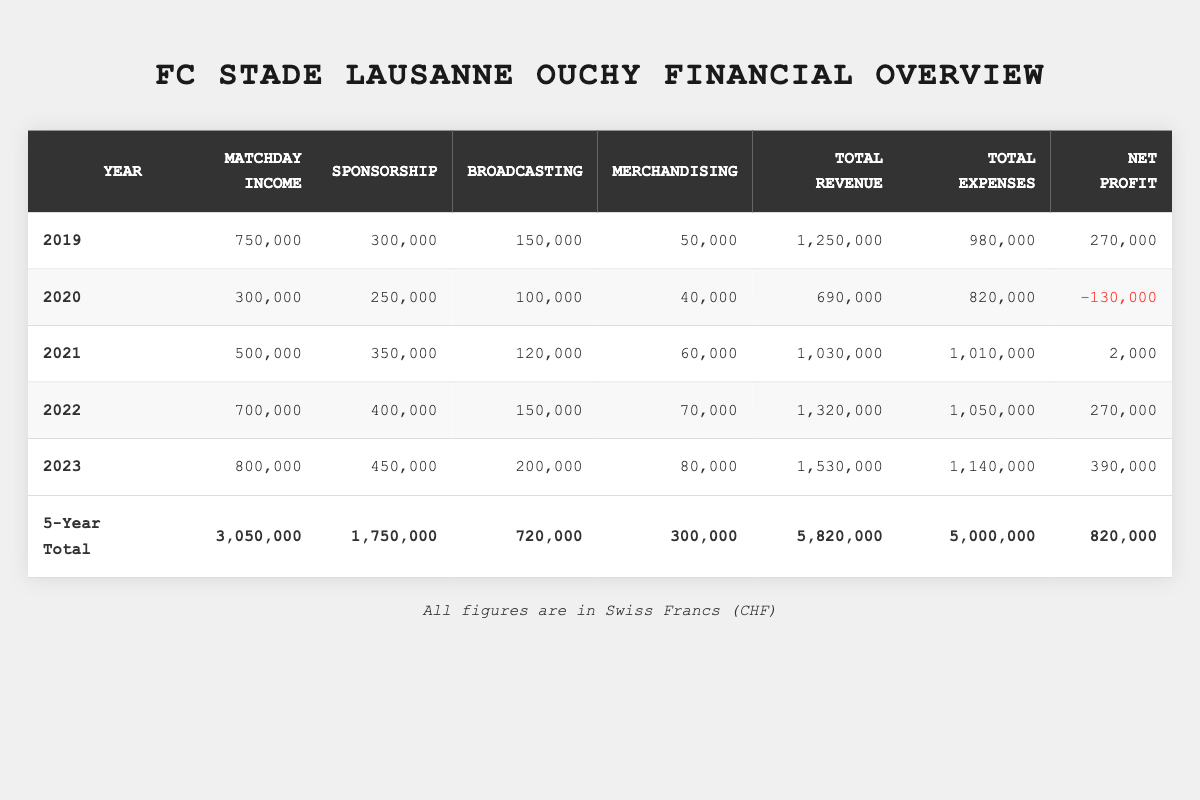What was the total revenue for FC Stade Lausanne Ouchy in 2022? The table shows that the total revenue for 2022 is listed directly under the "Total Revenue" column, which is 1,320,000 CHF.
Answer: 1,320,000 CHF What were the matchday income and total expenses in 2021? The matchday income for 2021 can be found directly in the table as 500,000 CHF, and total expenses are listed as 1,010,000 CHF.
Answer: Matchday income: 500,000 CHF; Total expenses: 1,010,000 CHF In which year did FC Stade Lausanne Ouchy first report a negative net profit? By examining the "Net Profit" column, we find that 2020 shows a negative value of -130,000 CHF.
Answer: 2020 What is the percentage increase in total revenue from 2021 to 2022? The total revenue in 2021 is 1,030,000 CHF and in 2022 it is 1,320,000 CHF. The increase is 1,320,000 - 1,030,000 = 290,000 CHF. To find the percentage increase, we divide by the original amount: (290,000 / 1,030,000) * 100% = approximately 28.16%.
Answer: Approximately 28.16% What was the average net profit over the five years? To find the average net profit, we first sum the net profits: 270,000 + (-130,000) + 2,000 + 270,000 + 390,000 = 802,000 CHF. Then we divide by the number of years (5): 802,000 / 5 = 160,400 CHF.
Answer: 160,400 CHF What year had the highest matchday income, and what was that amount? In reviewing the matchday income from the table, 2023 has the highest value at 800,000 CHF, as compared to previous years.
Answer: 2023; 800,000 CHF Was the total expenses in 2023 greater than the total revenue in 2020? The total expenses for 2023 are 1,140,000 CHF, and the total revenue for 2020 is 690,000 CHF. Since 1,140,000 CHF is greater than 690,000 CHF, the answer is yes.
Answer: Yes What is the change in net profit from 2019 to 2023? The net profit in 2019 was 270,000 CHF and in 2023 it became 390,000 CHF. To find the change, we calculate: 390,000 - 270,000 = 120,000 CHF increase.
Answer: 120,000 CHF increase Which year had the lowest total expenses, and what were they? Looking at the "Total Expenses" column, the year with the lowest total expenses is 2020, which amounted to 820,000 CHF.
Answer: 2020; 820,000 CHF How much total revenue was lost from 2019 to 2020? The total revenue for 2019 is 1,250,000 CHF and for 2020 is 690,000 CHF. The loss is calculated as follows: 1,250,000 - 690,000 = 560,000 CHF.
Answer: 560,000 CHF Is the sum of matchday income greater than the sum of merchandising income over the five years? The total matchday income over five years is 3,050,000 CHF, while the total merchandising income is 300,000 CHF. Since 3,050,000 CHF is greater than 300,000 CHF, the answer is yes.
Answer: Yes 